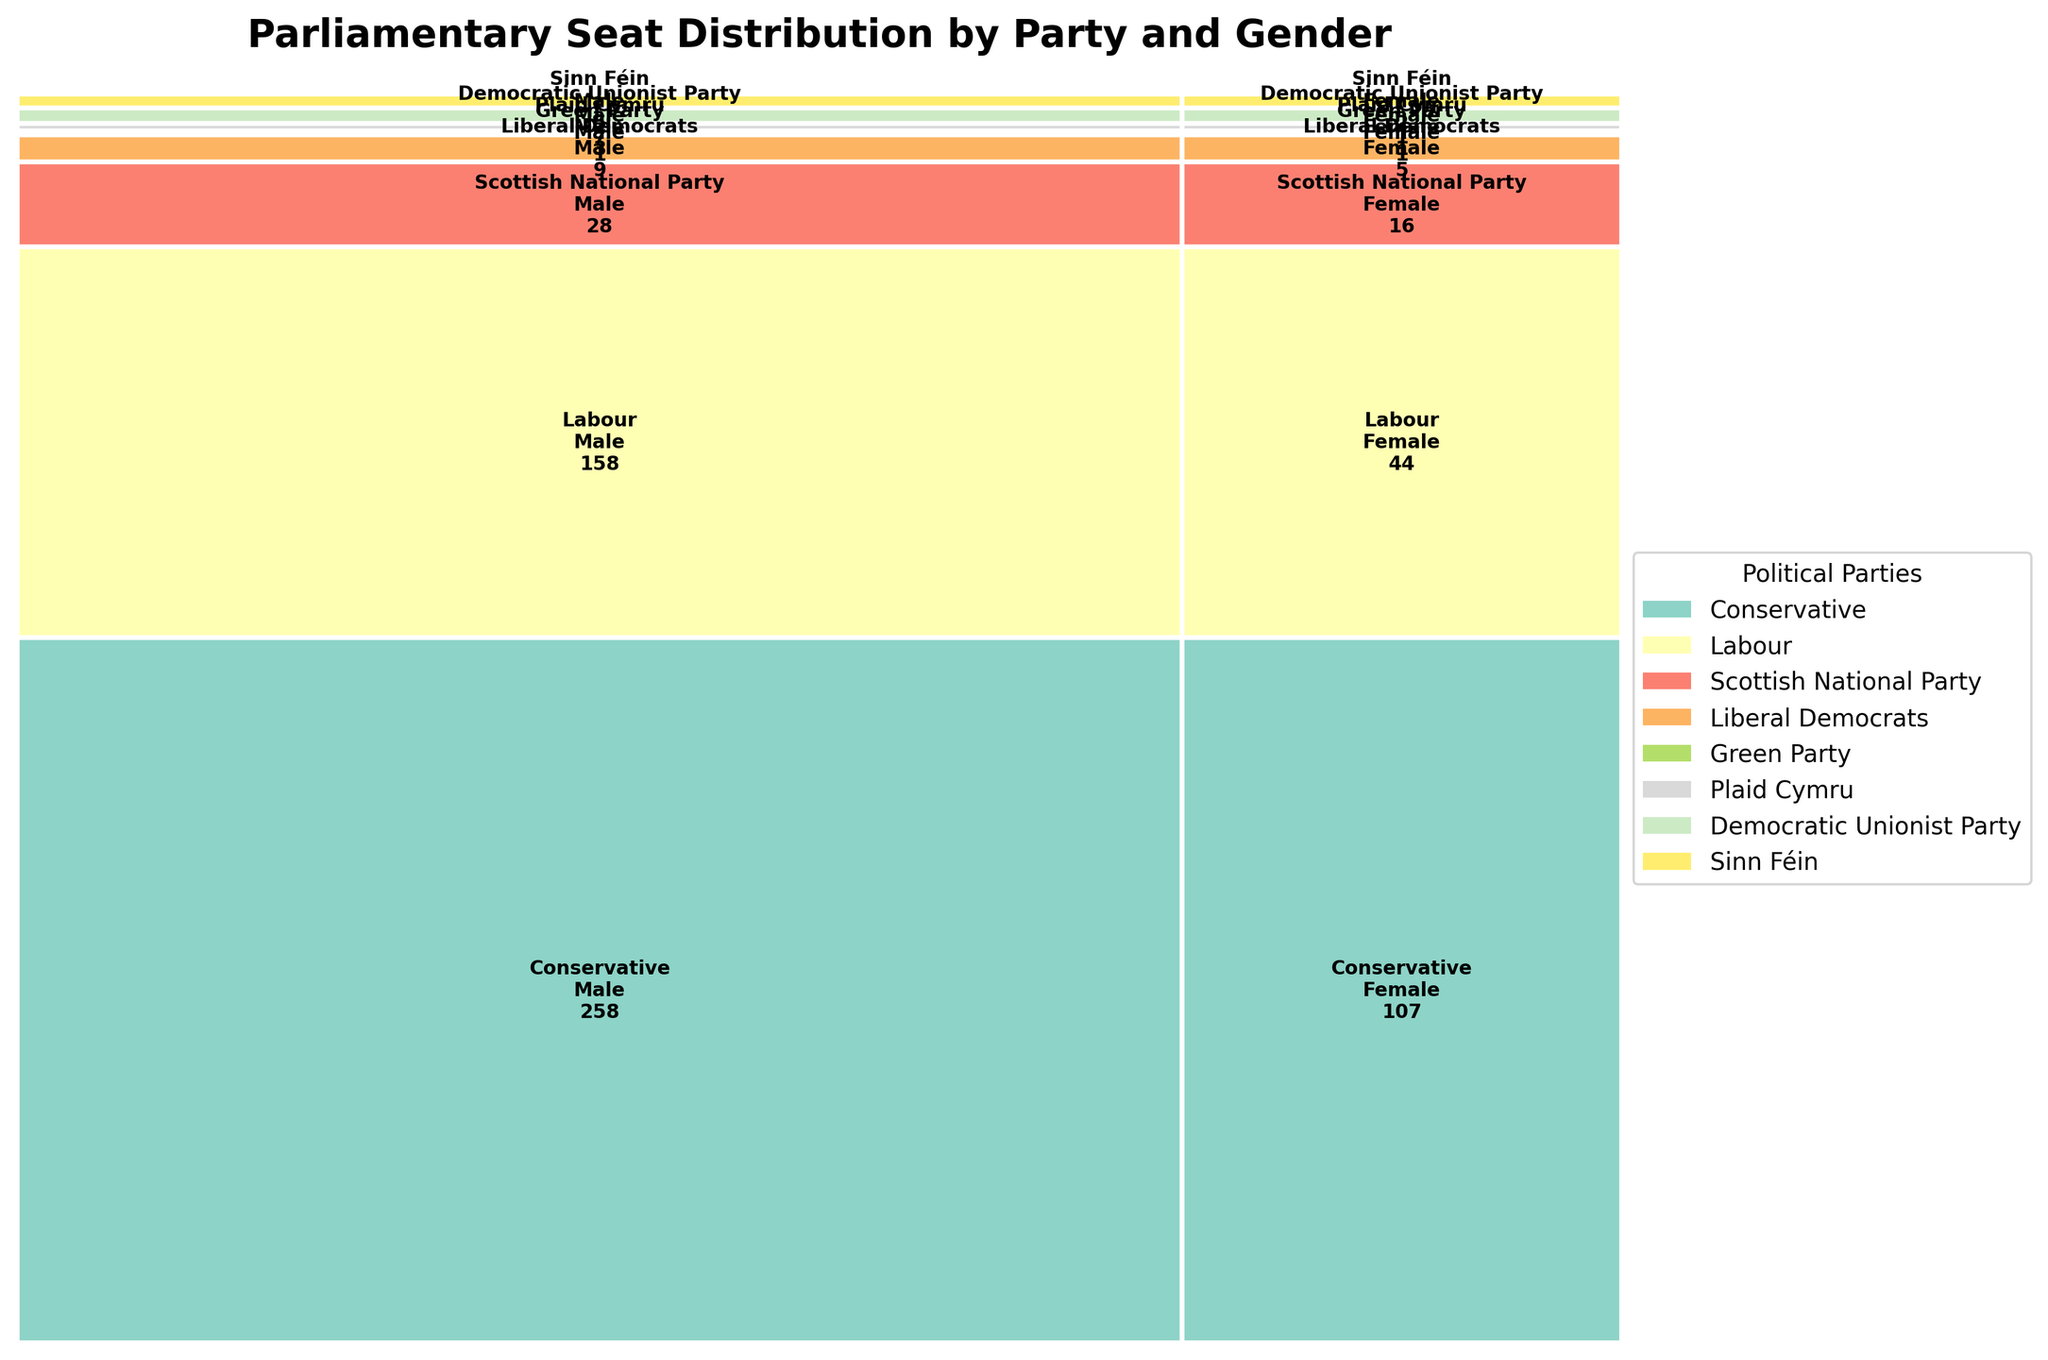What is the title of the figure? The title of the figure is located at the top and summarizes the content it represents.
Answer: Parliamentary Seat Distribution by Party and Gender How many seats do the Conservative party males hold? Find the "Conservative" section and then look for the "Male" segment to see the seat count.
Answer: 258 Which gender has more seats in the Labour party? Compare the sizes of the "Male" and "Female" segments within the "Labour" section and note the one with the larger number. The "Male" shows 158, and the "Female" shows 44.
Answer: Male What is the sum of seats for female members from all parties combined? Sum the female seat counts from the figure for all parties: Conservative (107) + Labour (44) + Scottish National Party (16) + Liberal Democrats (5) + Green Party (1) + Plaid Cymru (1) + Democratic Unionist Party (1) + Sinn Féin (2).
Answer: 177 Which party has the least number of seats overall? Compare the total sizes of each party's segment (both male and female). Identify the party with the smallest combined segment. The "Green Party" has 1 male and 1 female seat, totaling 2.
Answer: Green Party How does the number of seats held by male Scottish National Party members compare to those held by female members of the same party? Locate the "Scottish National Party" segment. Compare the "Male" (28) and "Female" (16) sections.
Answer: Males hold more seats What is the total number of seats held by the Democratic Unionist Party (DUP)? Sum the male and female seat numbers for the "Democratic Unionist Party": 7 males + 1 female.
Answer: 8 Are there any parties where females hold more seats than males? Evaluate each party's male and female seat segments. None show females with more seats than males.
Answer: No Which party has the largest difference in seat numbers between males and females? Calculate the difference between male and female seats for each party. The "Conservative" party has the largest difference: 258 males - 107 females = 151.
Answer: Conservative What proportion of the total seats are held by female members of the Liberal Democrats? Calculate the total number of seats (856), then calculate the proportion of seats held by Liberal Democrat females (5) by dividing it by the total seats: 5/856.
Answer: Approximately 0.58% 